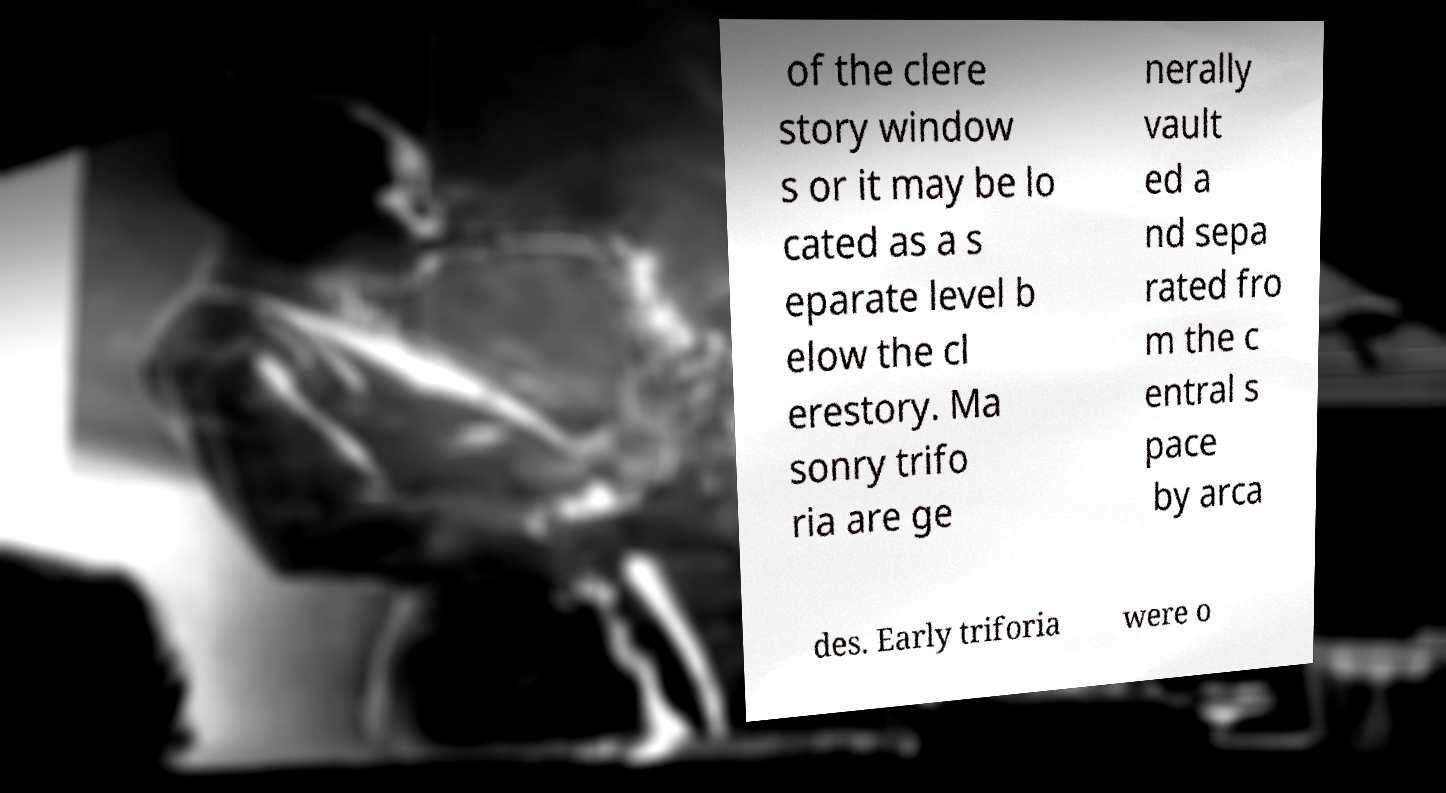For documentation purposes, I need the text within this image transcribed. Could you provide that? of the clere story window s or it may be lo cated as a s eparate level b elow the cl erestory. Ma sonry trifo ria are ge nerally vault ed a nd sepa rated fro m the c entral s pace by arca des. Early triforia were o 